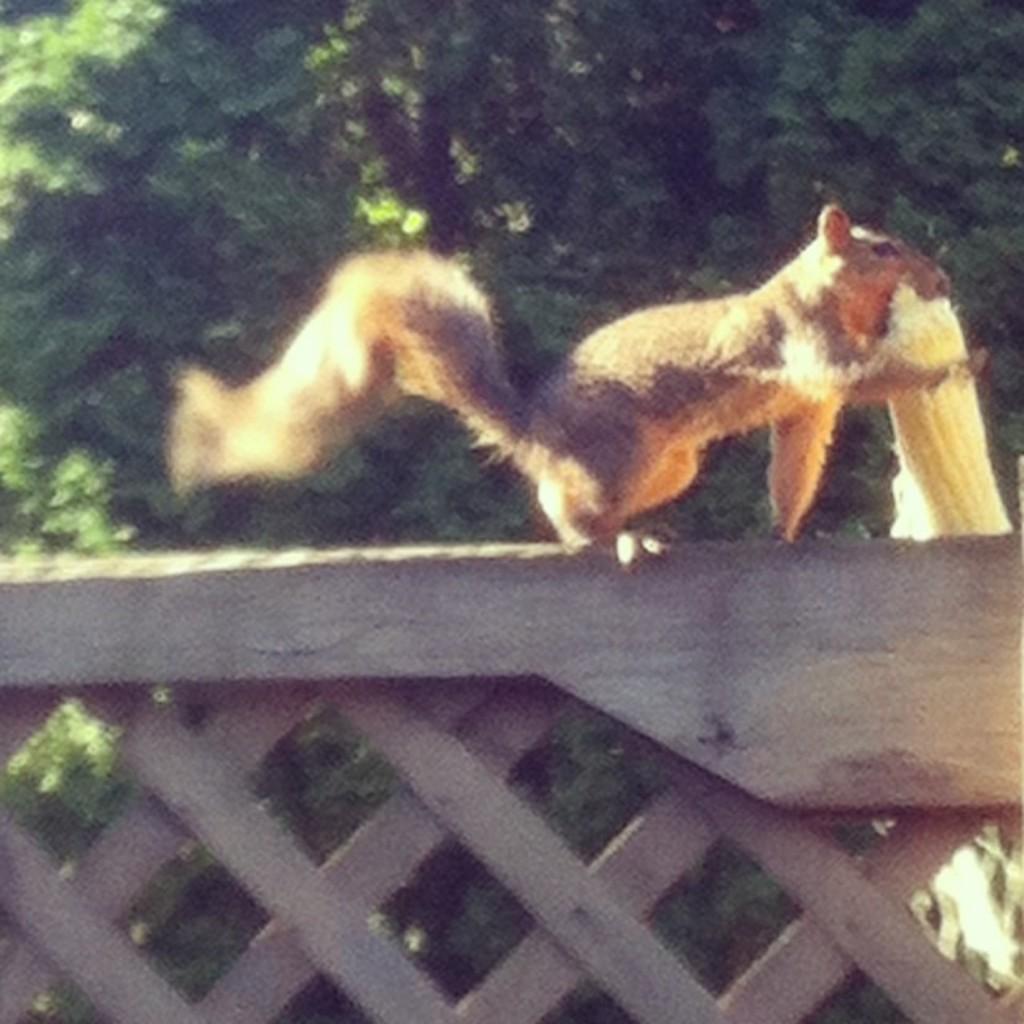Please provide a concise description of this image. On this wooden mesh there is a Squirrel. Background there is a tree. 